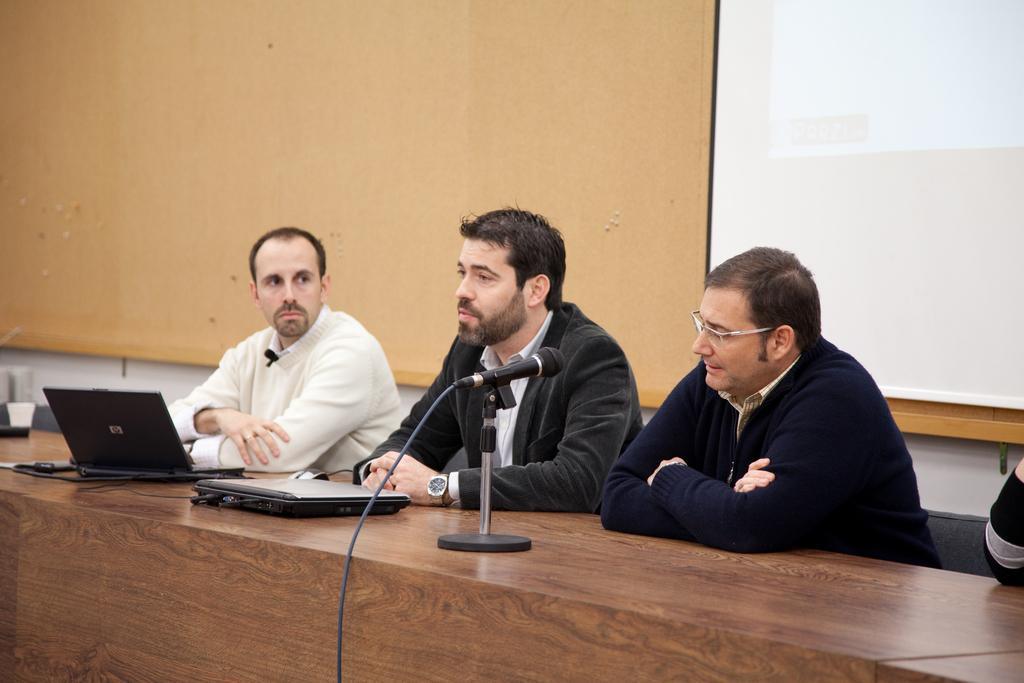Please provide a concise description of this image. In this image there are a few people sitting in chairs, in front of them on the table there are laptops, mic and some other objects, behind them there is a screen on the wall. 